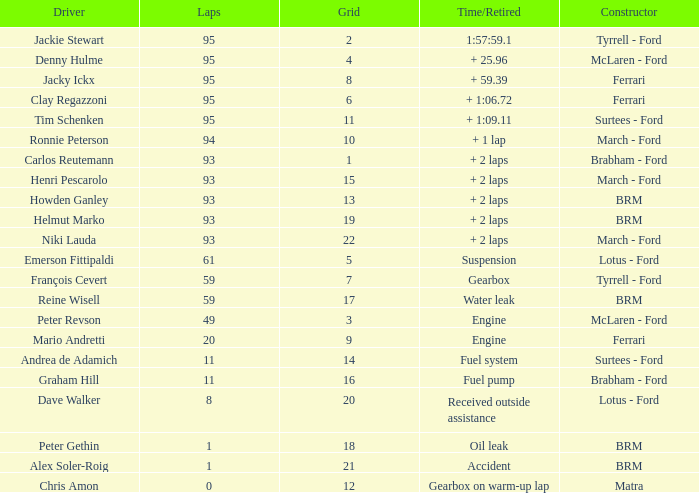What is the largest number of laps with a Grid larger than 14, a Time/Retired of + 2 laps, and a Driver of helmut marko? 93.0. 